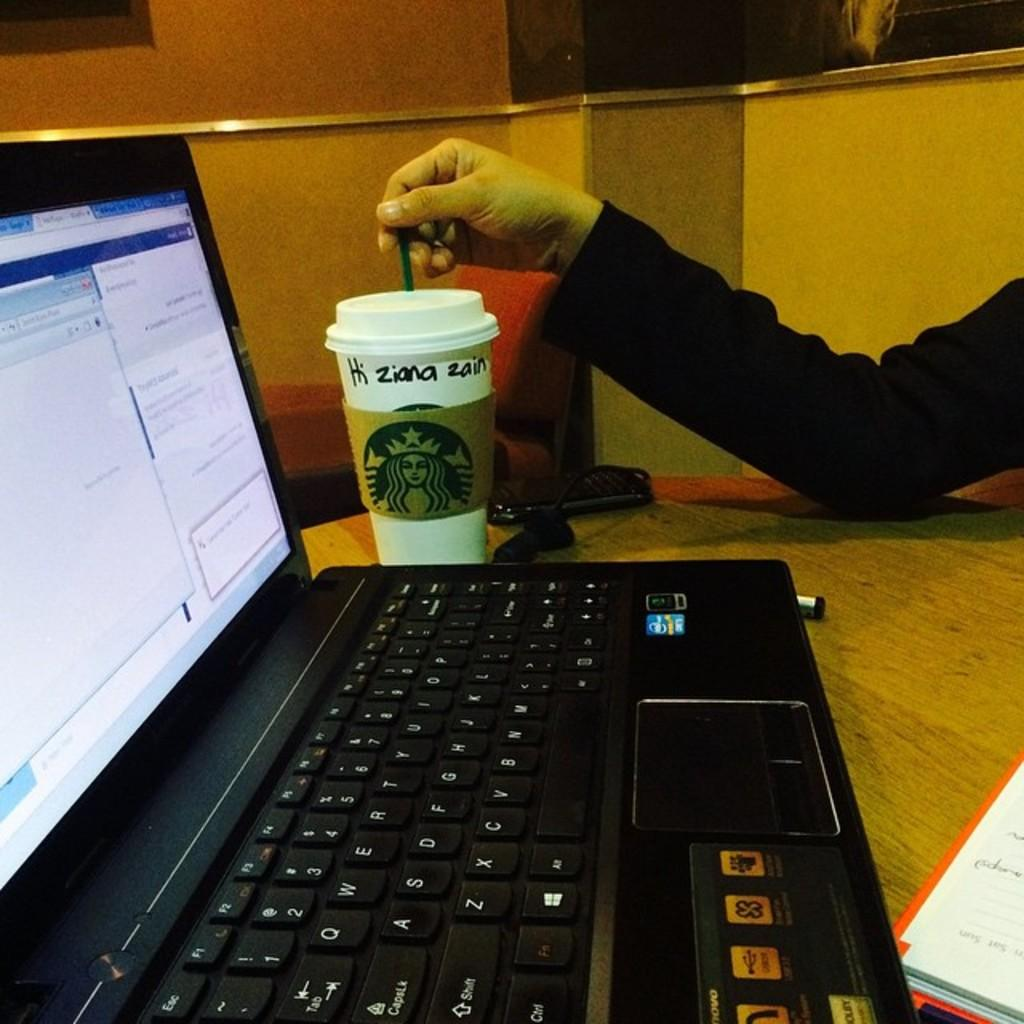What electronic device is on the table in the image? There is a laptop on the table in the image. What type of beverage is associated with the laptop? There is a Starbucks coffee cup on the table. Can you read any text on the coffee cup? Yes, the text "HI ZIANA ZAIN" is written on the coffee cup. What type of treatment is being administered to the laptop in the image? There is no treatment being administered to the laptop in the image; it is simply sitting on the table. 